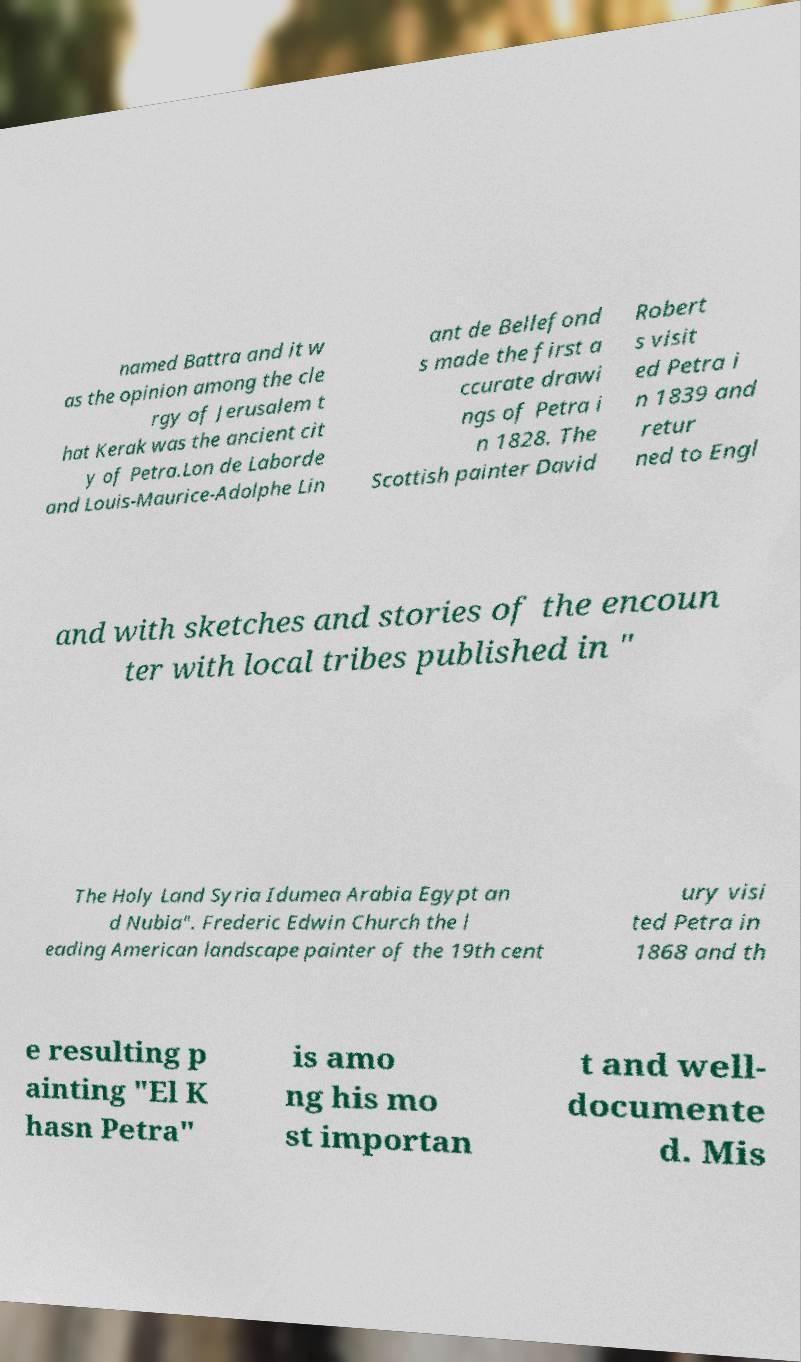What messages or text are displayed in this image? I need them in a readable, typed format. named Battra and it w as the opinion among the cle rgy of Jerusalem t hat Kerak was the ancient cit y of Petra.Lon de Laborde and Louis-Maurice-Adolphe Lin ant de Bellefond s made the first a ccurate drawi ngs of Petra i n 1828. The Scottish painter David Robert s visit ed Petra i n 1839 and retur ned to Engl and with sketches and stories of the encoun ter with local tribes published in " The Holy Land Syria Idumea Arabia Egypt an d Nubia". Frederic Edwin Church the l eading American landscape painter of the 19th cent ury visi ted Petra in 1868 and th e resulting p ainting "El K hasn Petra" is amo ng his mo st importan t and well- documente d. Mis 